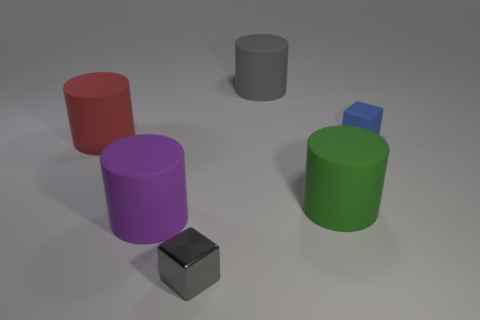Are there fewer things to the right of the big red cylinder than matte cylinders?
Ensure brevity in your answer.  No. What color is the small cube that is in front of the cube that is behind the tiny cube that is left of the large green thing?
Make the answer very short. Gray. Is there anything else that has the same material as the big purple object?
Ensure brevity in your answer.  Yes. There is a green matte thing that is the same shape as the big red rubber object; what size is it?
Provide a succinct answer. Large. Are there fewer big matte cylinders that are right of the big purple rubber cylinder than red cylinders behind the tiny blue object?
Offer a terse response. No. What is the shape of the thing that is to the right of the purple matte cylinder and on the left side of the large gray rubber cylinder?
Give a very brief answer. Cube. There is a purple object that is made of the same material as the large gray object; what size is it?
Your answer should be very brief. Large. There is a metallic block; is it the same color as the small block behind the red cylinder?
Make the answer very short. No. What material is the object that is in front of the green object and behind the gray metallic block?
Make the answer very short. Rubber. What is the size of the object that is the same color as the metallic block?
Keep it short and to the point. Large. 